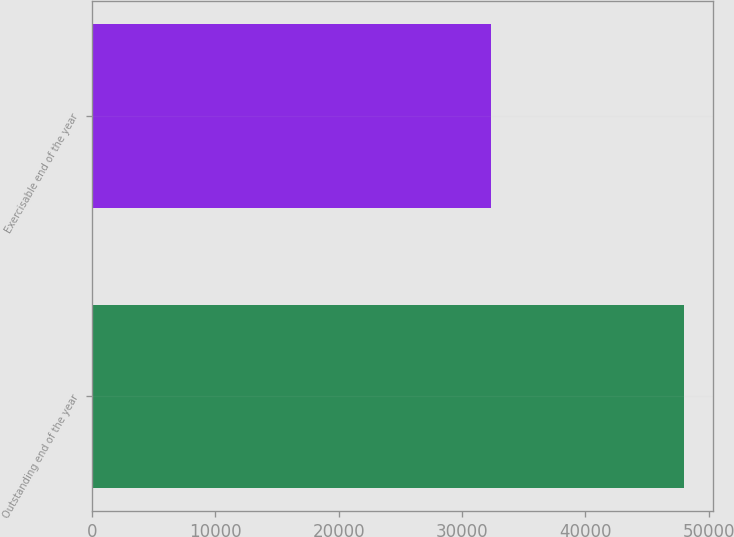Convert chart. <chart><loc_0><loc_0><loc_500><loc_500><bar_chart><fcel>Outstanding end of the year<fcel>Exercisable end of the year<nl><fcel>47974<fcel>32373<nl></chart> 